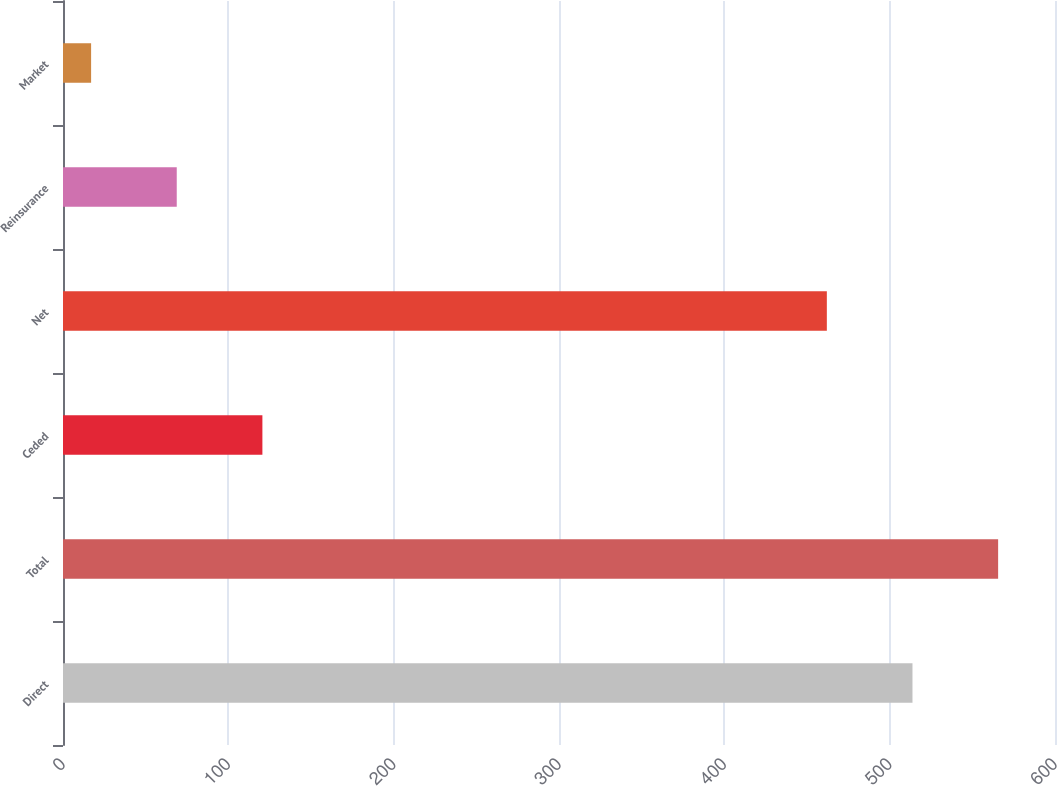Convert chart. <chart><loc_0><loc_0><loc_500><loc_500><bar_chart><fcel>Direct<fcel>Total<fcel>Ceded<fcel>Net<fcel>Reinsurance<fcel>Market<nl><fcel>513.8<fcel>565.6<fcel>120.6<fcel>462<fcel>68.8<fcel>17<nl></chart> 